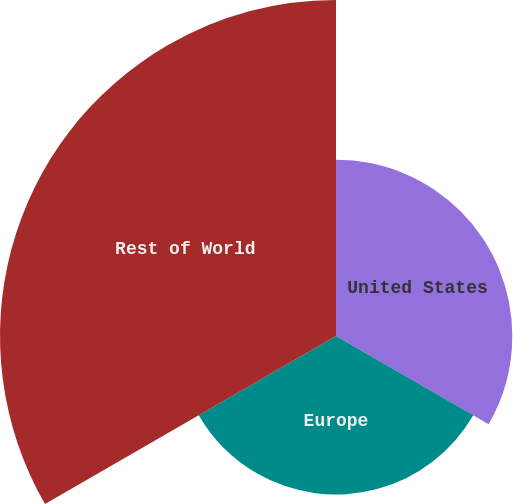Convert chart to OTSL. <chart><loc_0><loc_0><loc_500><loc_500><pie_chart><fcel>United States<fcel>Europe<fcel>Rest of World<nl><fcel>26.28%<fcel>23.63%<fcel>50.09%<nl></chart> 